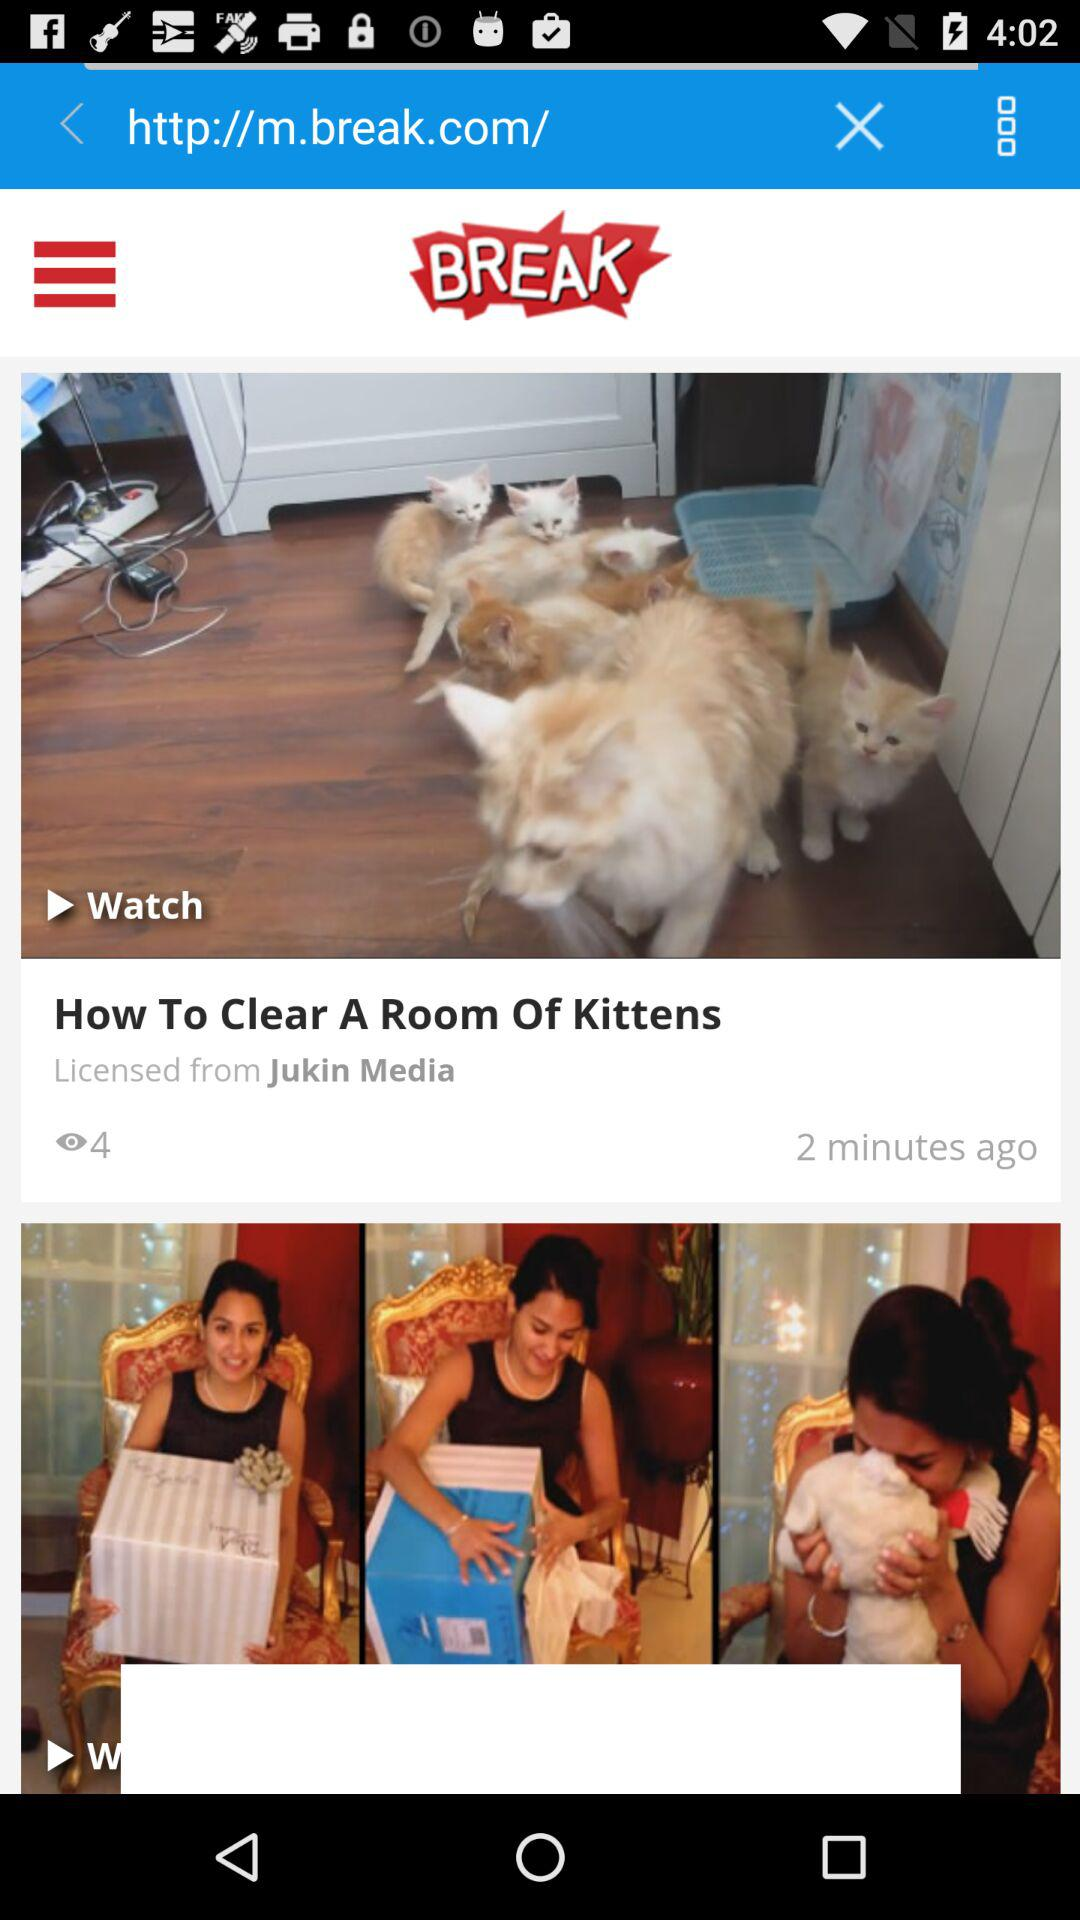What is the name of the application? The name of the application is "Break.com". 